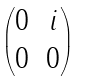<formula> <loc_0><loc_0><loc_500><loc_500>\begin{pmatrix} 0 & i \\ 0 & 0 \end{pmatrix}</formula> 